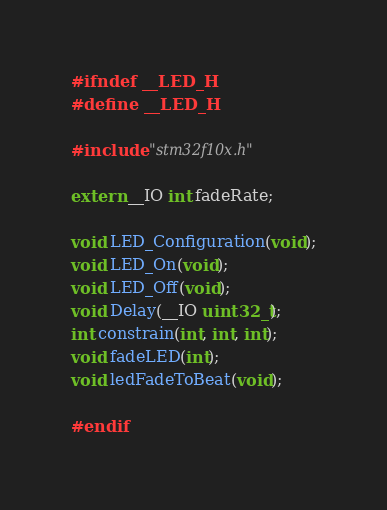<code> <loc_0><loc_0><loc_500><loc_500><_C_>#ifndef __LED_H
#define __LED_H

#include "stm32f10x.h"

extern __IO int fadeRate;

void LED_Configuration(void);
void LED_On(void);
void LED_Off(void);
void Delay(__IO uint32_t);
int constrain(int, int, int);
void fadeLED(int);
void ledFadeToBeat(void);

#endif
</code> 